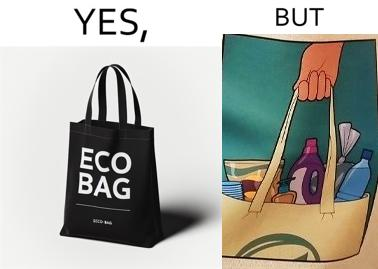What is shown in this image? The image is ironical because in the left image it is written eco bag but in the right image we are keeping items of plastic which is not eco-friendly. 